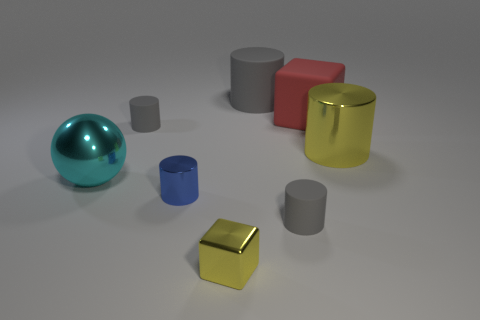Do the tiny metal block and the big rubber block have the same color?
Give a very brief answer. No. What number of blocks are either gray shiny things or big metallic things?
Your response must be concise. 0. The cylinder that is behind the small blue object and left of the small metallic cube is made of what material?
Your answer should be very brief. Rubber. What number of large cubes are behind the large gray rubber thing?
Give a very brief answer. 0. Is the material of the gray cylinder in front of the large yellow shiny cylinder the same as the red object that is behind the large cyan metal object?
Offer a very short reply. Yes. How many objects are yellow objects in front of the big yellow metallic object or cyan rubber objects?
Ensure brevity in your answer.  1. Are there fewer small gray cylinders behind the big ball than big cubes in front of the small yellow thing?
Keep it short and to the point. No. What number of other things are there of the same size as the yellow cylinder?
Provide a short and direct response. 3. Is the material of the yellow cylinder the same as the gray object that is right of the big gray rubber thing?
Offer a terse response. No. What number of things are either tiny gray rubber objects left of the big gray matte cylinder or gray cylinders that are behind the large cyan ball?
Your answer should be very brief. 2. 